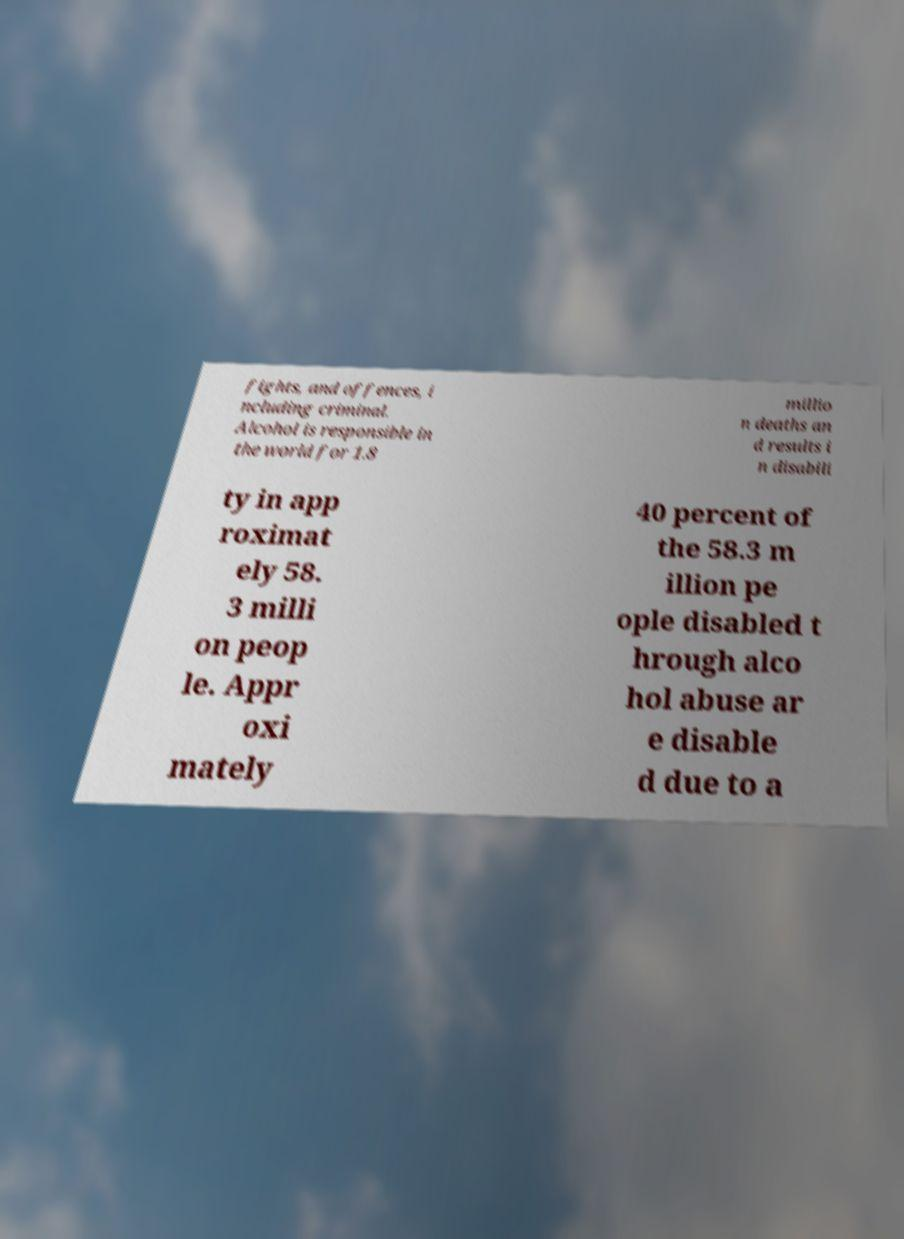Could you assist in decoding the text presented in this image and type it out clearly? fights, and offences, i ncluding criminal. Alcohol is responsible in the world for 1.8 millio n deaths an d results i n disabili ty in app roximat ely 58. 3 milli on peop le. Appr oxi mately 40 percent of the 58.3 m illion pe ople disabled t hrough alco hol abuse ar e disable d due to a 